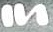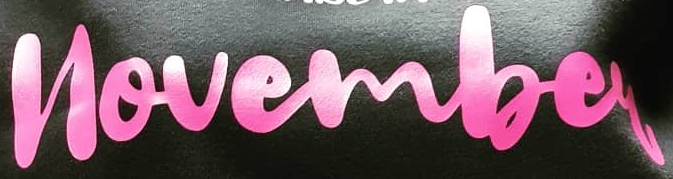What words are shown in these images in order, separated by a semicolon? In; novembey 